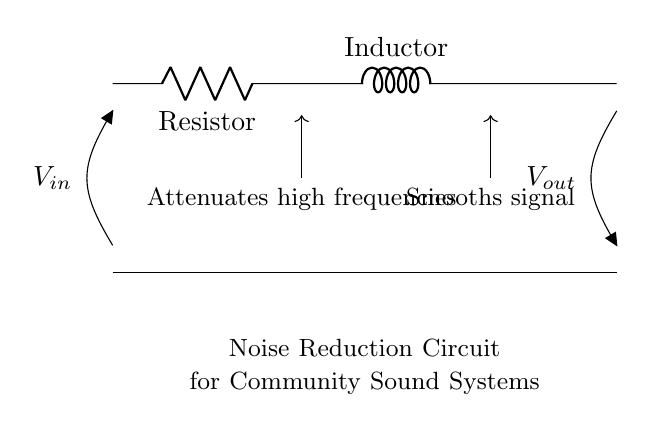What are the components in the circuit? The circuit contains a resistor and an inductor, which are labeled as R and L respectively.
Answer: Resistor and Inductor What is the purpose of the resistor in this circuit? The resistor is used to limit the current and helps in attenuating high frequencies in the signal.
Answer: Attenuates high frequencies What does the inductor do in this circuit? The inductor smooths the signal by storing energy in its magnetic field and releasing it, helping to reduce noise.
Answer: Smooths signal What is the input voltage source labeled in the diagram? The voltage input source is labeled as V in, indicating the voltage supplied to the circuit.
Answer: V in What is V out in this circuit? V out is the output voltage, which represents the voltage across the load after noise reduction by the resistor and inductor.
Answer: V out How is the output voltage related to the circuit components? The output voltage is influenced by the resistive and inductive properties, which affect the circuit's response to different frequencies.
Answer: Influenced by R and L 